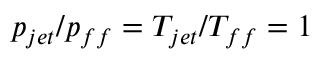<formula> <loc_0><loc_0><loc_500><loc_500>p _ { j e t } / p _ { f f } = T _ { j e t } / T _ { f f } = 1</formula> 